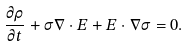Convert formula to latex. <formula><loc_0><loc_0><loc_500><loc_500>\frac { \partial \rho } { \partial t } + \sigma \nabla \cdot E + E \cdot \nabla \sigma = 0 .</formula> 